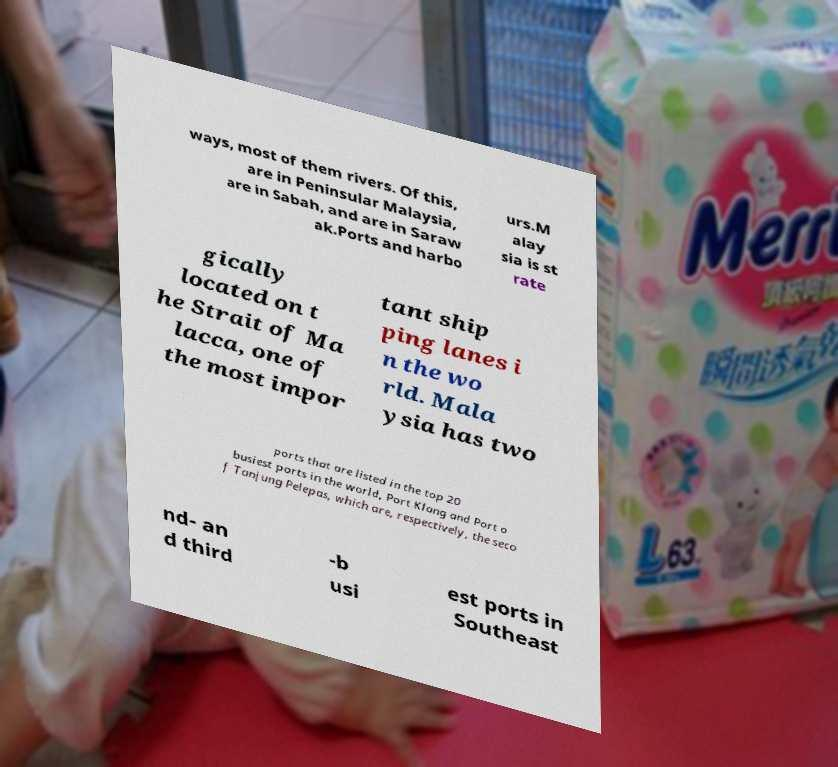Can you accurately transcribe the text from the provided image for me? ways, most of them rivers. Of this, are in Peninsular Malaysia, are in Sabah, and are in Saraw ak.Ports and harbo urs.M alay sia is st rate gically located on t he Strait of Ma lacca, one of the most impor tant ship ping lanes i n the wo rld. Mala ysia has two ports that are listed in the top 20 busiest ports in the world, Port Klang and Port o f Tanjung Pelepas, which are, respectively, the seco nd- an d third -b usi est ports in Southeast 